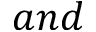<formula> <loc_0><loc_0><loc_500><loc_500>a n d</formula> 